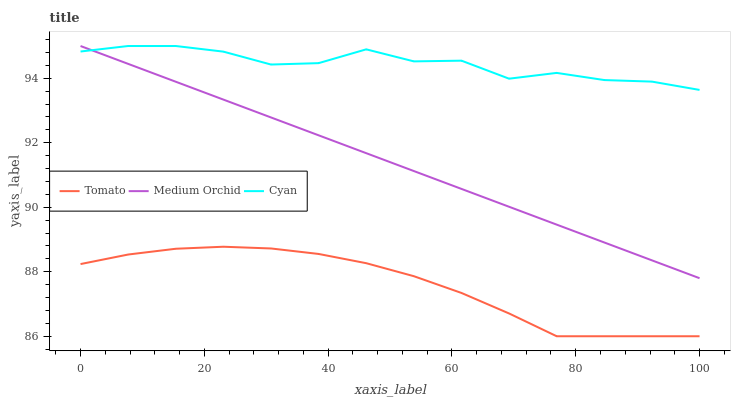Does Tomato have the minimum area under the curve?
Answer yes or no. Yes. Does Cyan have the maximum area under the curve?
Answer yes or no. Yes. Does Medium Orchid have the minimum area under the curve?
Answer yes or no. No. Does Medium Orchid have the maximum area under the curve?
Answer yes or no. No. Is Medium Orchid the smoothest?
Answer yes or no. Yes. Is Cyan the roughest?
Answer yes or no. Yes. Is Cyan the smoothest?
Answer yes or no. No. Is Medium Orchid the roughest?
Answer yes or no. No. Does Tomato have the lowest value?
Answer yes or no. Yes. Does Medium Orchid have the lowest value?
Answer yes or no. No. Does Medium Orchid have the highest value?
Answer yes or no. Yes. Is Tomato less than Cyan?
Answer yes or no. Yes. Is Cyan greater than Tomato?
Answer yes or no. Yes. Does Cyan intersect Medium Orchid?
Answer yes or no. Yes. Is Cyan less than Medium Orchid?
Answer yes or no. No. Is Cyan greater than Medium Orchid?
Answer yes or no. No. Does Tomato intersect Cyan?
Answer yes or no. No. 